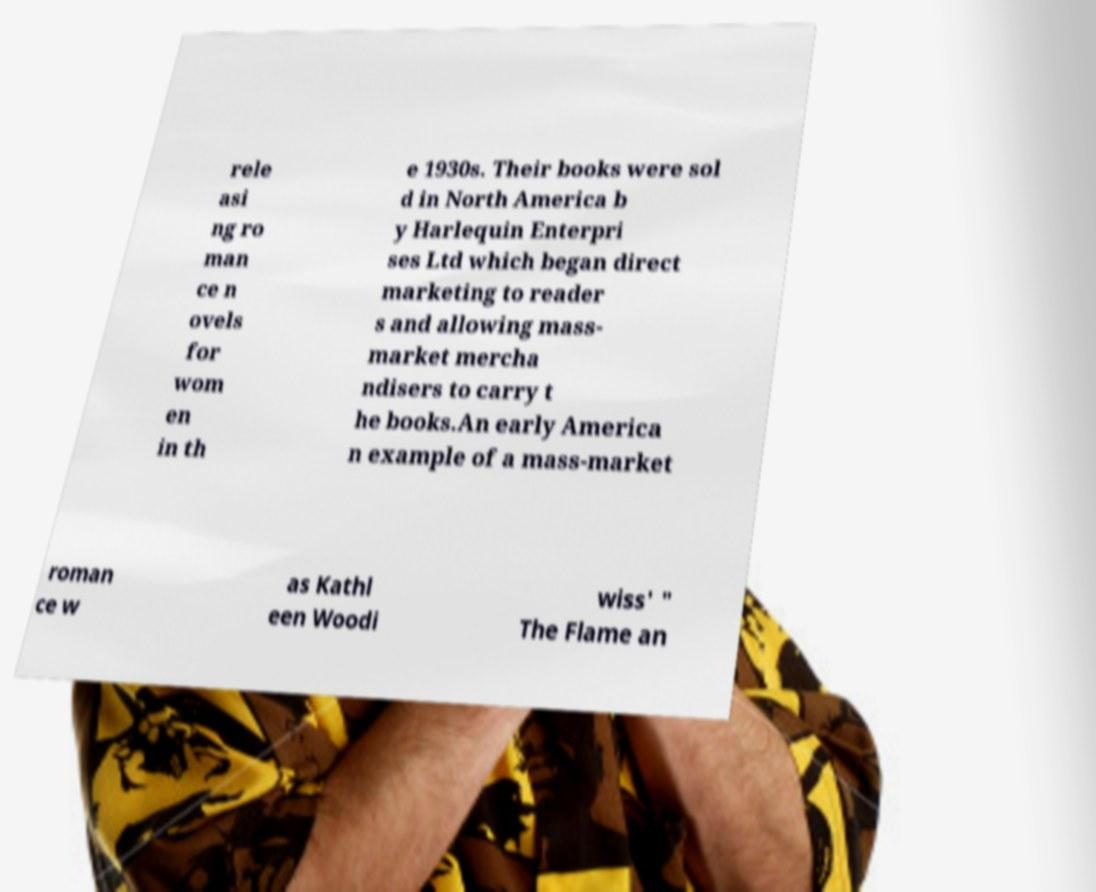Could you assist in decoding the text presented in this image and type it out clearly? rele asi ng ro man ce n ovels for wom en in th e 1930s. Their books were sol d in North America b y Harlequin Enterpri ses Ltd which began direct marketing to reader s and allowing mass- market mercha ndisers to carry t he books.An early America n example of a mass-market roman ce w as Kathl een Woodi wiss' " The Flame an 